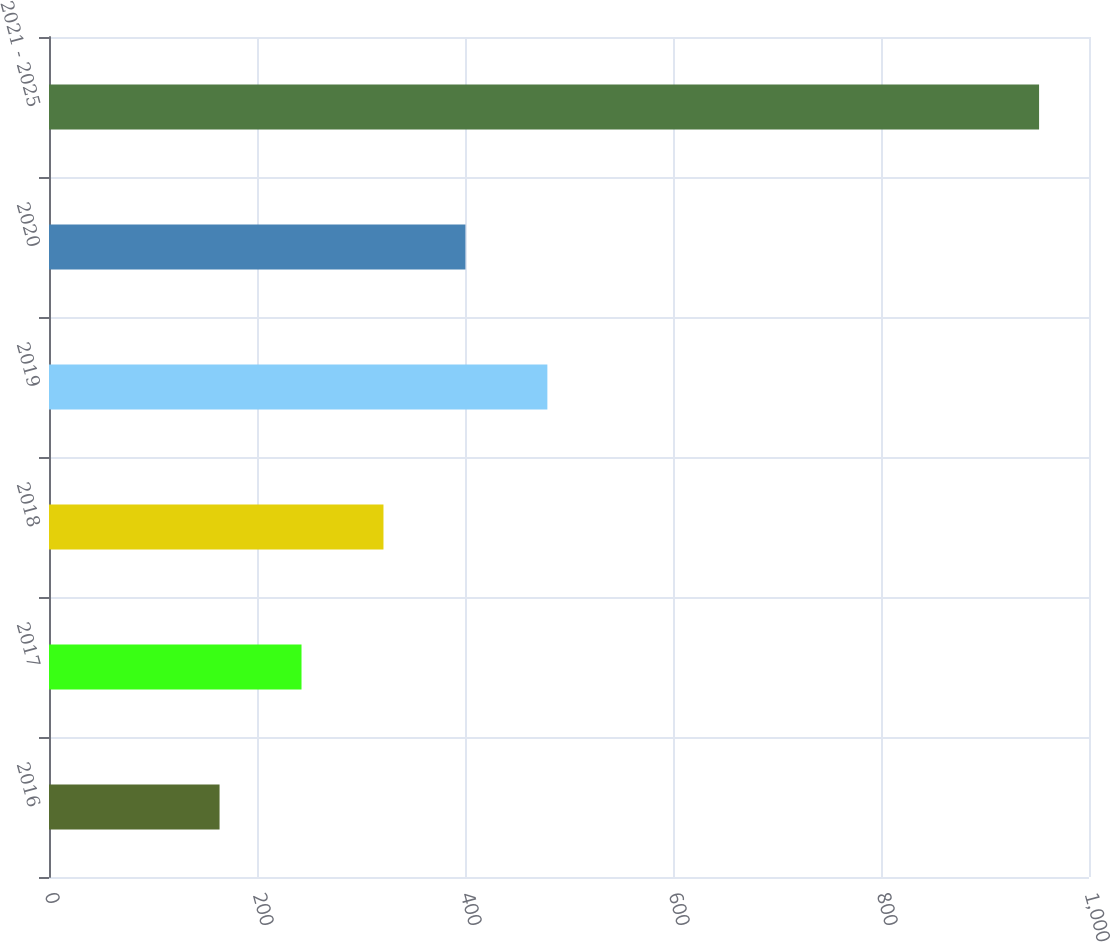Convert chart. <chart><loc_0><loc_0><loc_500><loc_500><bar_chart><fcel>2016<fcel>2017<fcel>2018<fcel>2019<fcel>2020<fcel>2021 - 2025<nl><fcel>164<fcel>242.8<fcel>321.6<fcel>479.2<fcel>400.4<fcel>952<nl></chart> 